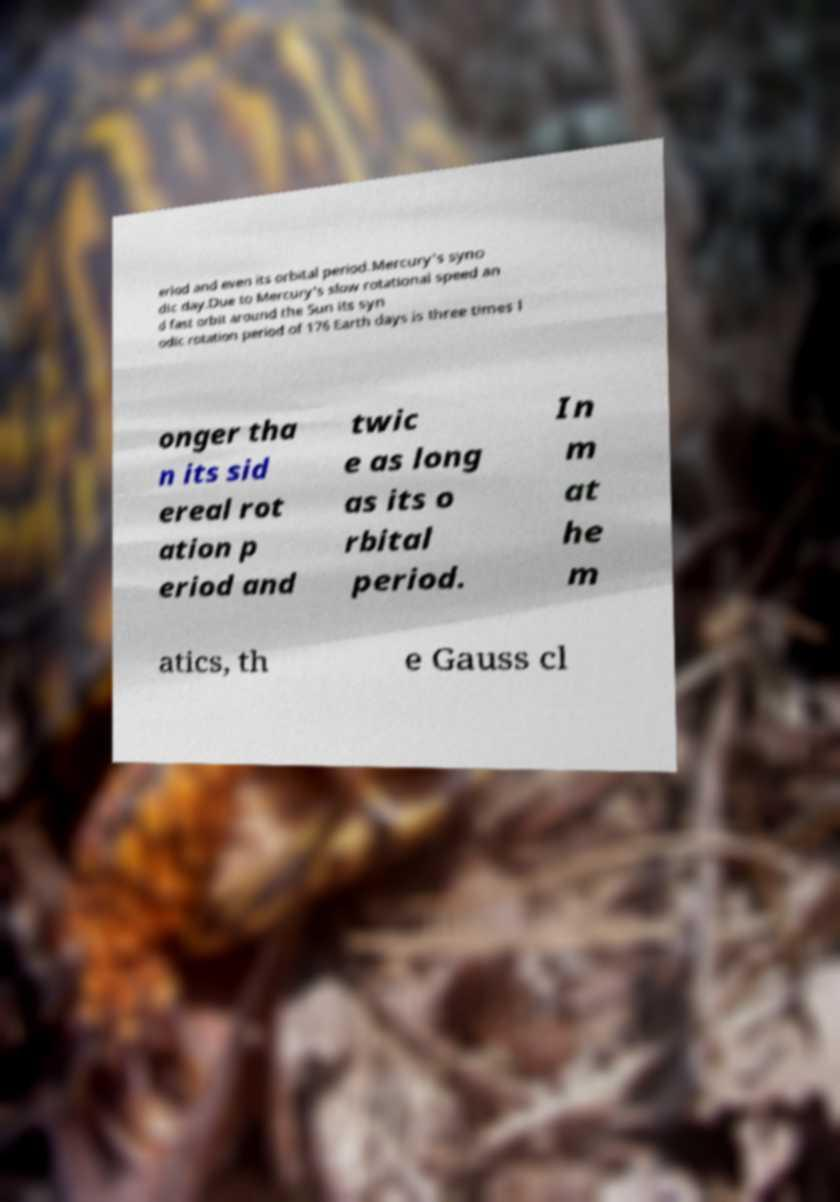Please identify and transcribe the text found in this image. eriod and even its orbital period.Mercury's syno dic day.Due to Mercury's slow rotational speed an d fast orbit around the Sun its syn odic rotation period of 176 Earth days is three times l onger tha n its sid ereal rot ation p eriod and twic e as long as its o rbital period. In m at he m atics, th e Gauss cl 